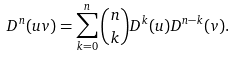Convert formula to latex. <formula><loc_0><loc_0><loc_500><loc_500>D ^ { n } ( u v ) = \sum _ { k = 0 } ^ { n } \binom { n } { k } D ^ { k } ( u ) D ^ { n - k } ( v ) .</formula> 